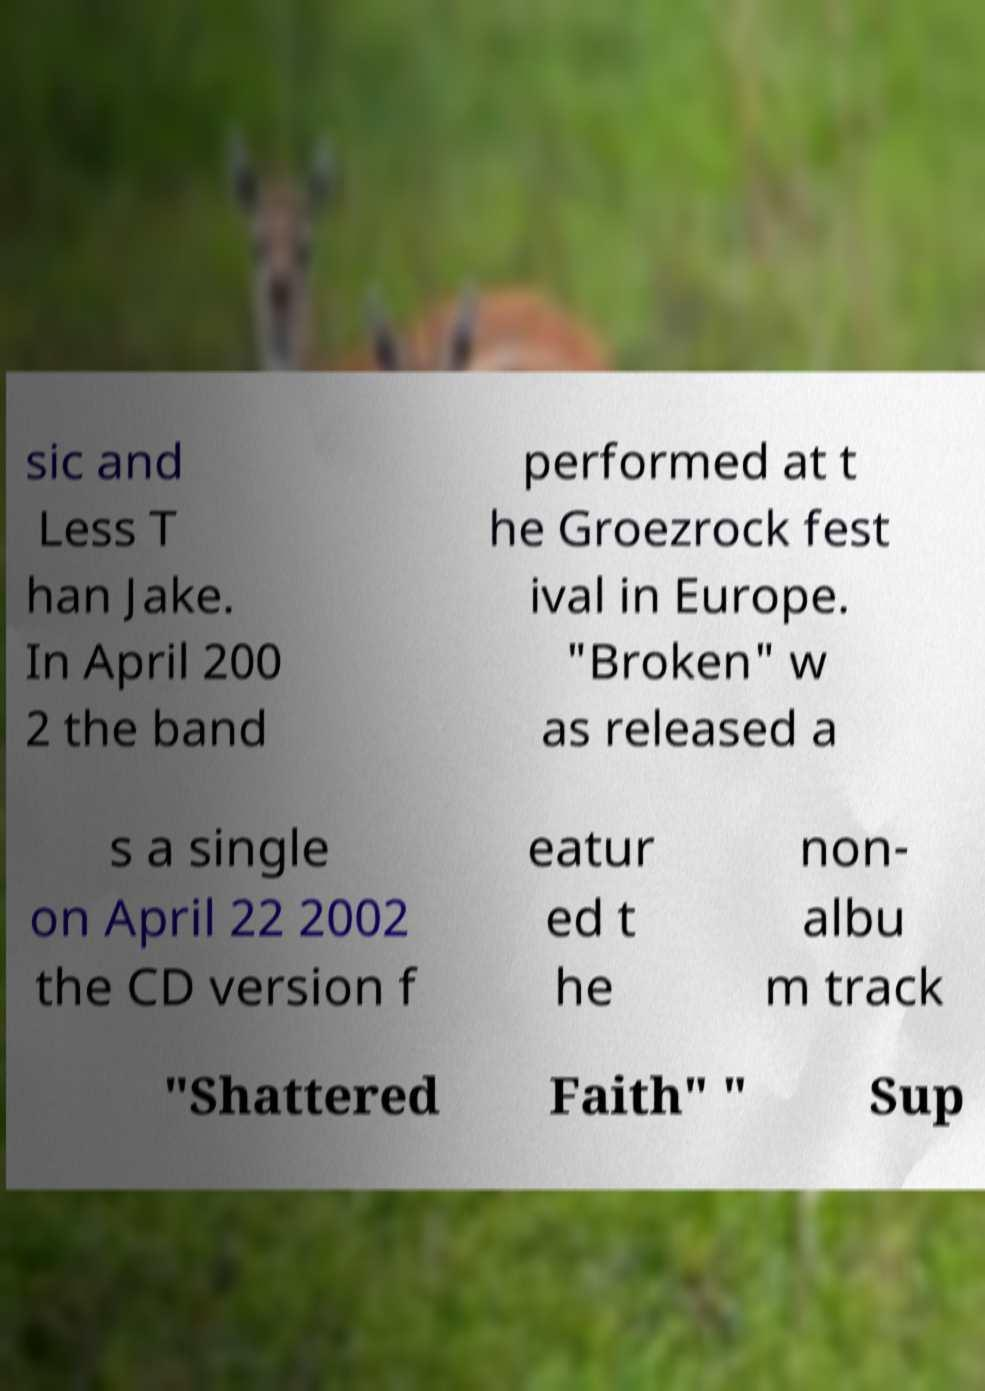Could you assist in decoding the text presented in this image and type it out clearly? sic and Less T han Jake. In April 200 2 the band performed at t he Groezrock fest ival in Europe. "Broken" w as released a s a single on April 22 2002 the CD version f eatur ed t he non- albu m track "Shattered Faith" " Sup 